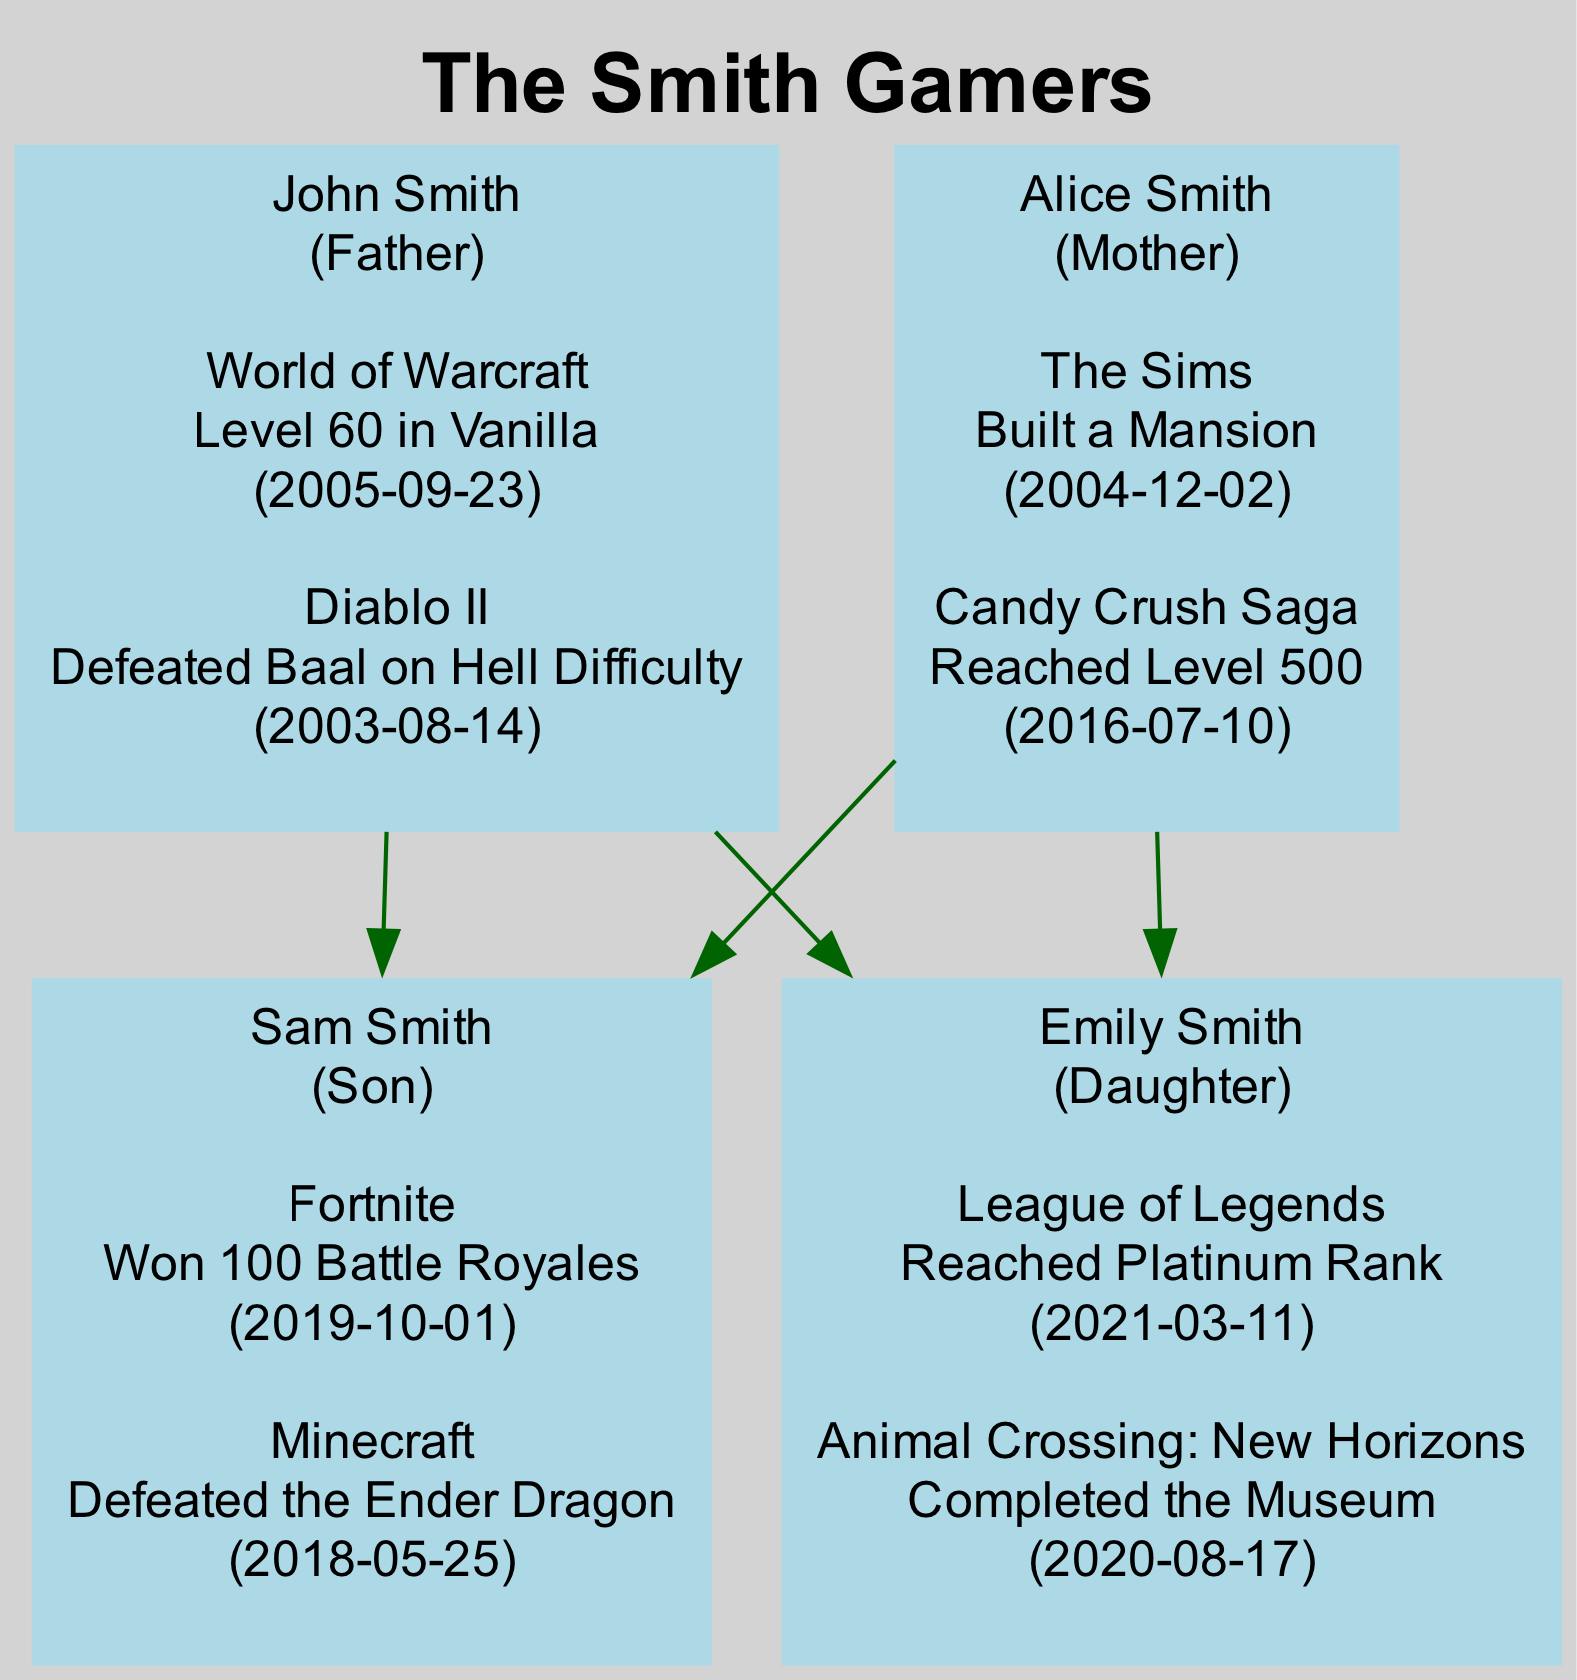What is the name of the father in the family tree? The father in the family tree is listed as "John Smith". Each family member is clearly labeled with their name and role.
Answer: John Smith How many members are in the Smith Gamers family? The family tree shows four members: John Smith, Alice Smith, Sam Smith, and Emily Smith. Counting each member individually leads to this total.
Answer: 4 What game did Alice Smith achieve a milestone in? Alice Smith has achievements in "The Sims" and "Candy Crush Saga". The question can be answered by referencing the achievements listed for each family member.
Answer: The Sims Who reached Platinum Rank in League of Legends? The achievement of reaching Platinum Rank in League of Legends belongs to "Emily Smith", as noted in her achievements section.
Answer: Emily Smith What relationship do Sam Smith and John Smith have? Sam Smith is the son of John Smith, as indicated by the connecting edges in the family tree diagram.
Answer: Son Which family member has the earliest achievement date? The earliest achievement is "Defeated Baal on Hell Difficulty" by John Smith on "2003-08-14", making it the earliest milestone in the family. The achievements are listed chronologically, so comparing dates reveals this.
Answer: John Smith How many games is John Smith recognized for? John Smith has two achievements listed: one for "World of Warcraft" and one for "Diablo II". By counting the achievements under his profile, we arrive at the total.
Answer: 2 Which member built a mansion, and in which game did they achieve it? Alice Smith built a mansion in "The Sims", as indicated by her achievement details. This information can be extracted directly from her list of gaming milestones.
Answer: Alice Smith, The Sims What milestone did Emily Smith complete in Animal Crossing: New Horizons? Emily Smith completed the museum in "Animal Crossing: New Horizons", which is documented in her achievements section. This provides a straightforward way to gather the necessary details.
Answer: Completed the Museum 